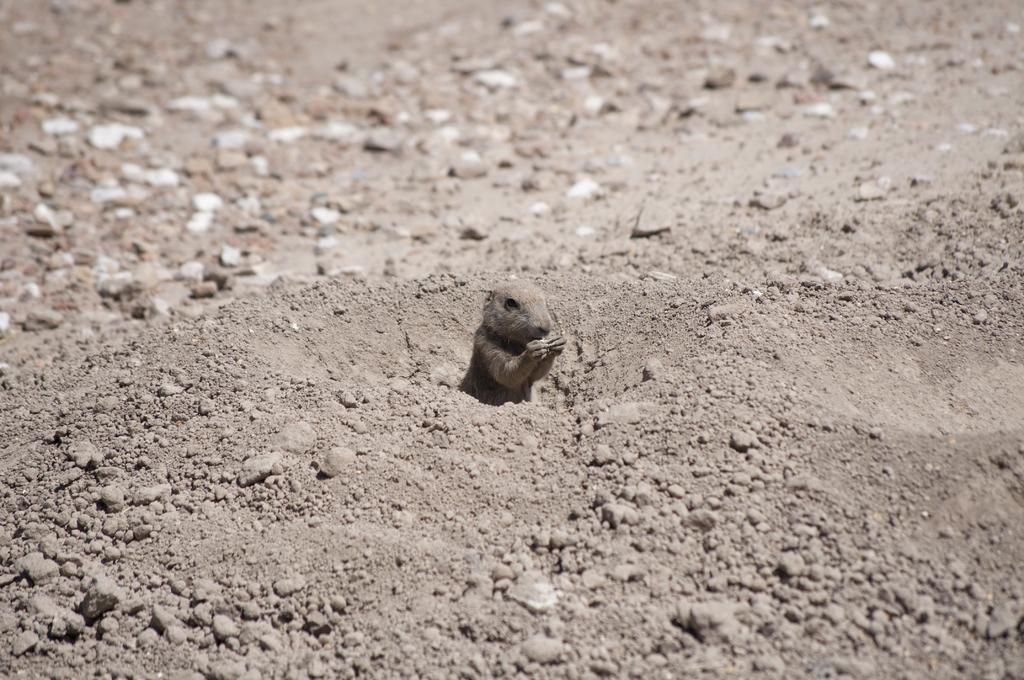What type of surface is visible in the image? There is ground visible in the image. What can be found on the ground in the image? There are small stones in the image. What type of living creature is present in the image? There is an animal in the image. What color is the animal in the image? The animal is brown in color. What type of chin is visible on the animal in the image? There is no chin visible on the animal in the image, as animals do not have chins like humans do. 